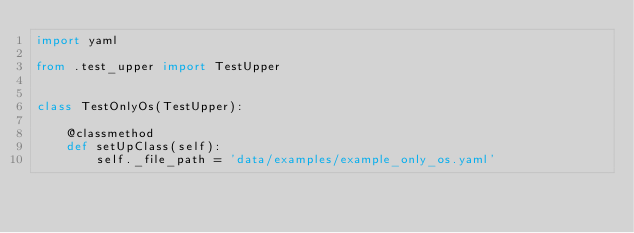<code> <loc_0><loc_0><loc_500><loc_500><_Python_>import yaml

from .test_upper import TestUpper


class TestOnlyOs(TestUpper):

    @classmethod
    def setUpClass(self):
        self._file_path = 'data/examples/example_only_os.yaml'</code> 